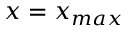<formula> <loc_0><loc_0><loc_500><loc_500>x = x _ { \max }</formula> 